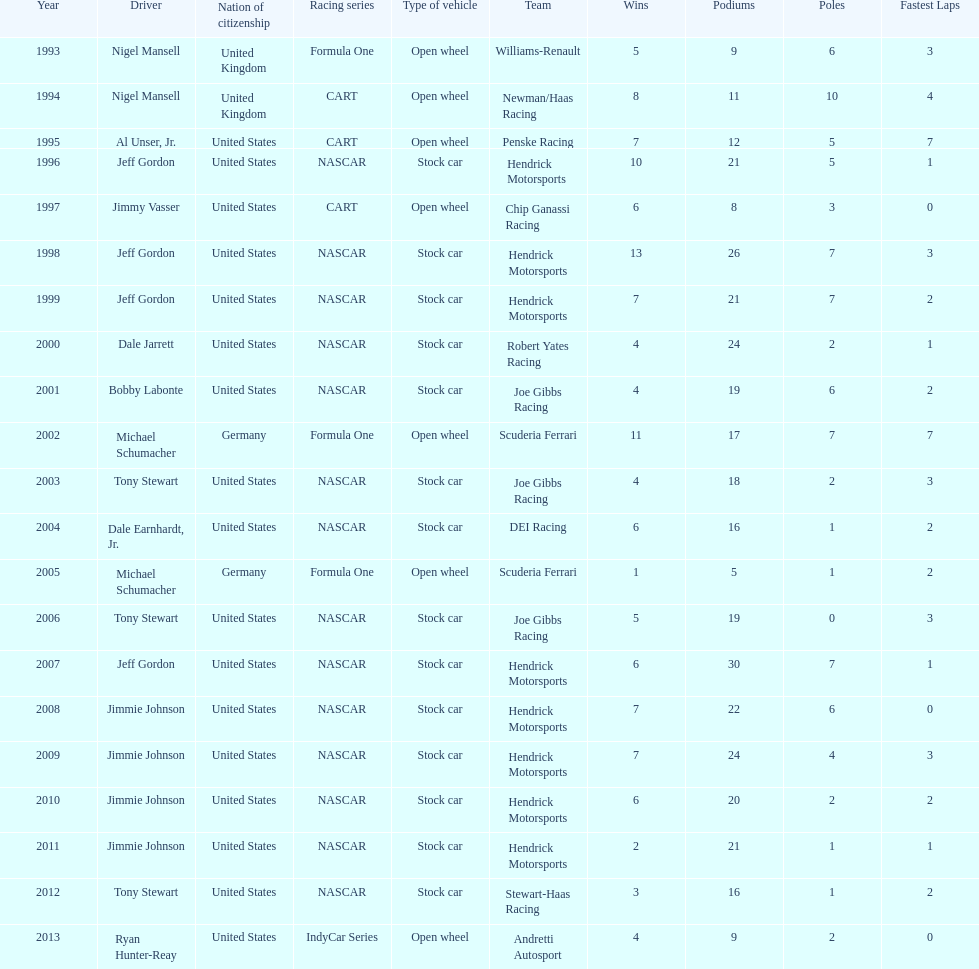Jimmy johnson won how many consecutive espy awards? 4. 